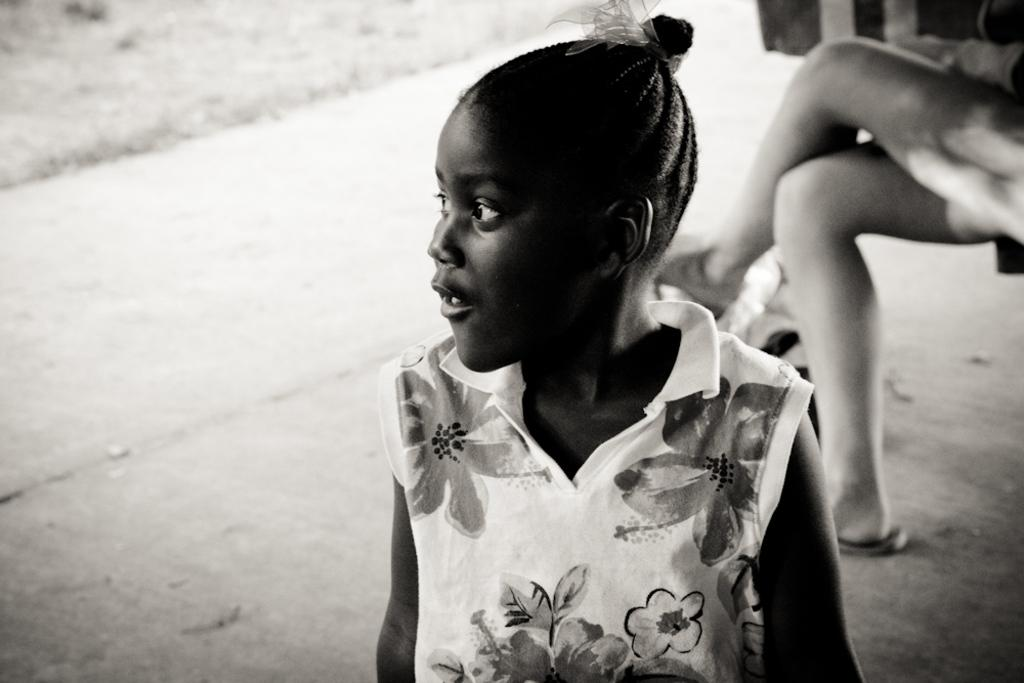What is the main subject of the image? The main subject of the image is a group of people. Can you describe the position of the girl in the image? The girl is standing in the middle of the image. What is the position of the person behind the girl? There is another person seated behind the girl. What is the girl teaching in the image? There is no indication in the image that the girl is teaching anything. 